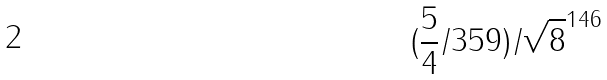<formula> <loc_0><loc_0><loc_500><loc_500>( \frac { 5 } { 4 } / 3 5 9 ) / \sqrt { 8 } ^ { 1 4 6 }</formula> 